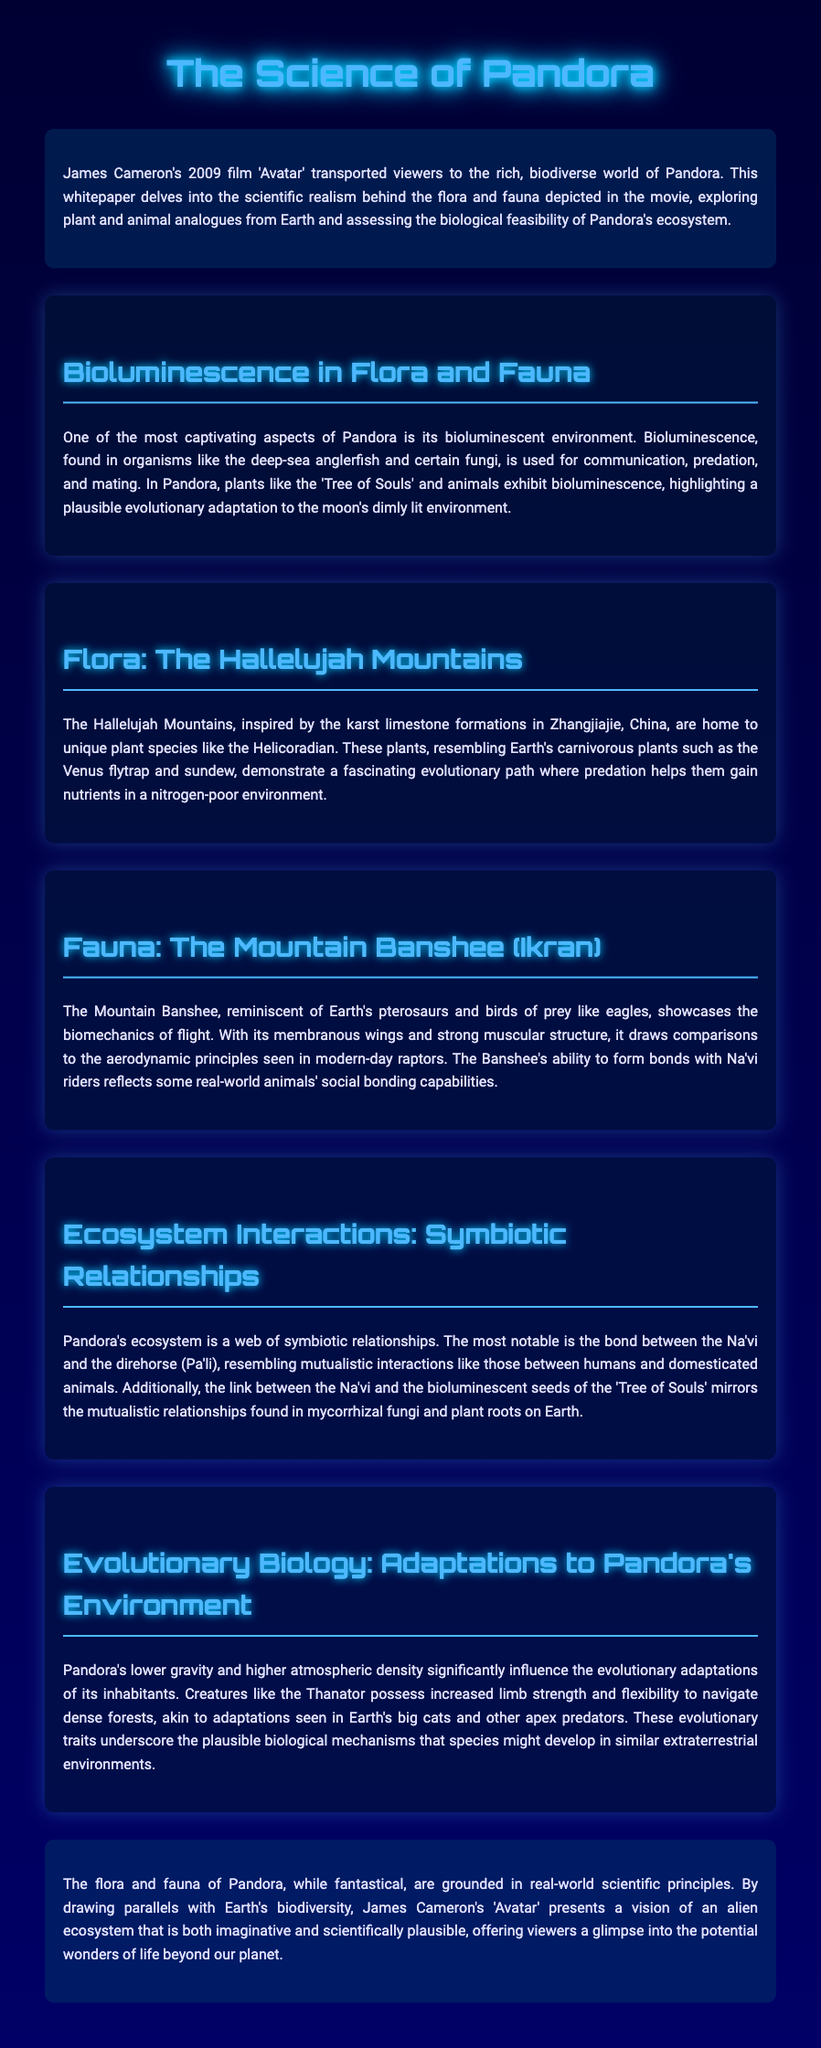What is the title of the document? The title of the document is prominently displayed at the top and is "The Science of Pandora."
Answer: The Science of Pandora What year was "Avatar" released? The document refers to the film "Avatar," which was released in 2009.
Answer: 2009 What plant is used as an example of bioluminescence? The document mentions the 'Tree of Souls' as an example of a bioluminescent plant on Pandora.
Answer: Tree of Souls What Earth species does the Helicoradian resemble? The Helicoradian is said to resemble Earth's carnivorous plants like the Venus flytrap and sundew.
Answer: Venus flytrap What is the name of the creature that reflects biomechanics of flight? The document talks about the Mountain Banshee, which exemplifies biomechanics of flight.
Answer: Mountain Banshee What type of relationship is highlighted between the Na'vi and direhorse? The document describes the relationship between the Na'vi and the direhorse as mutualistic.
Answer: Mutualistic Which adaptation is noted for the Thanator? The document mentions increased limb strength and flexibility as adaptations of the Thanator.
Answer: Increased limb strength and flexibility What theme does the document ultimately conclude with regarding Pandora? The conclusion emphasizes the scientific plausibility of Pandora's flora and fauna, linking them to Earth's biodiversity.
Answer: Scientific plausibility 